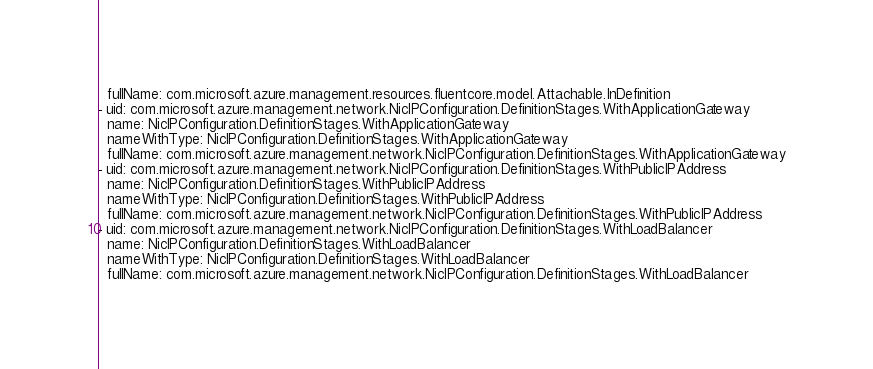Convert code to text. <code><loc_0><loc_0><loc_500><loc_500><_YAML_>  fullName: com.microsoft.azure.management.resources.fluentcore.model.Attachable.InDefinition
- uid: com.microsoft.azure.management.network.NicIPConfiguration.DefinitionStages.WithApplicationGateway
  name: NicIPConfiguration.DefinitionStages.WithApplicationGateway
  nameWithType: NicIPConfiguration.DefinitionStages.WithApplicationGateway
  fullName: com.microsoft.azure.management.network.NicIPConfiguration.DefinitionStages.WithApplicationGateway
- uid: com.microsoft.azure.management.network.NicIPConfiguration.DefinitionStages.WithPublicIPAddress
  name: NicIPConfiguration.DefinitionStages.WithPublicIPAddress
  nameWithType: NicIPConfiguration.DefinitionStages.WithPublicIPAddress
  fullName: com.microsoft.azure.management.network.NicIPConfiguration.DefinitionStages.WithPublicIPAddress
- uid: com.microsoft.azure.management.network.NicIPConfiguration.DefinitionStages.WithLoadBalancer
  name: NicIPConfiguration.DefinitionStages.WithLoadBalancer
  nameWithType: NicIPConfiguration.DefinitionStages.WithLoadBalancer
  fullName: com.microsoft.azure.management.network.NicIPConfiguration.DefinitionStages.WithLoadBalancer
</code> 